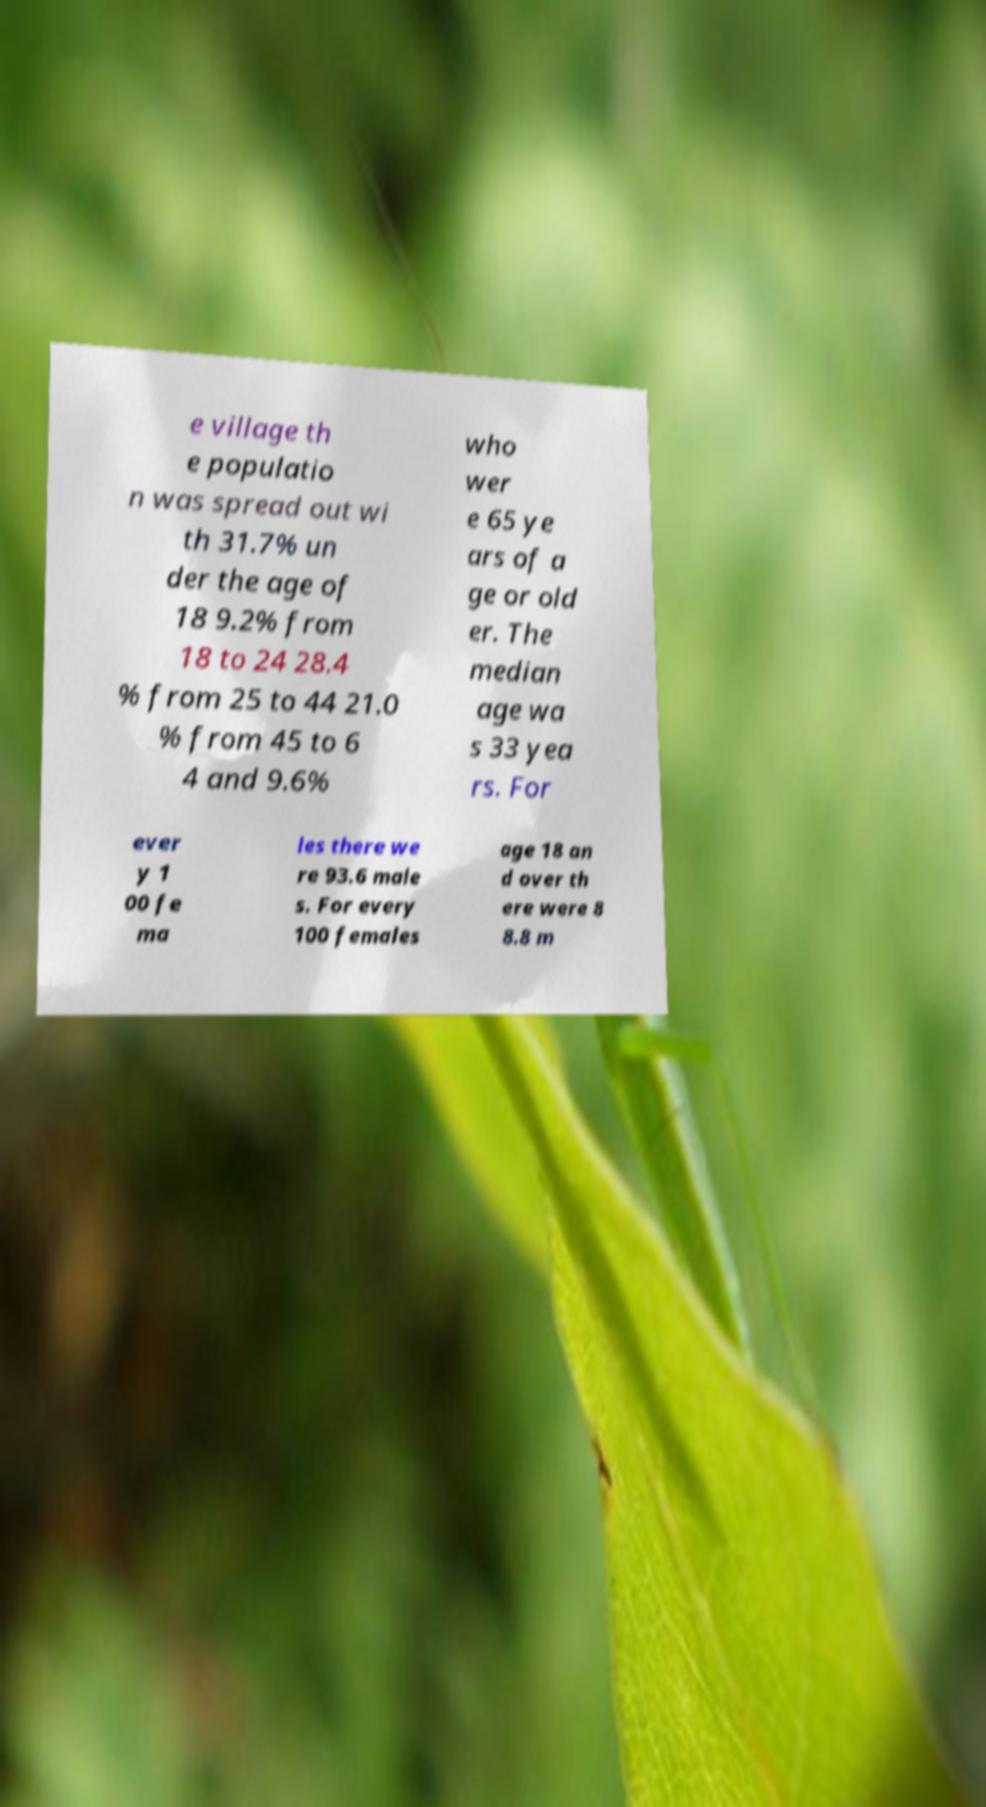For documentation purposes, I need the text within this image transcribed. Could you provide that? e village th e populatio n was spread out wi th 31.7% un der the age of 18 9.2% from 18 to 24 28.4 % from 25 to 44 21.0 % from 45 to 6 4 and 9.6% who wer e 65 ye ars of a ge or old er. The median age wa s 33 yea rs. For ever y 1 00 fe ma les there we re 93.6 male s. For every 100 females age 18 an d over th ere were 8 8.8 m 